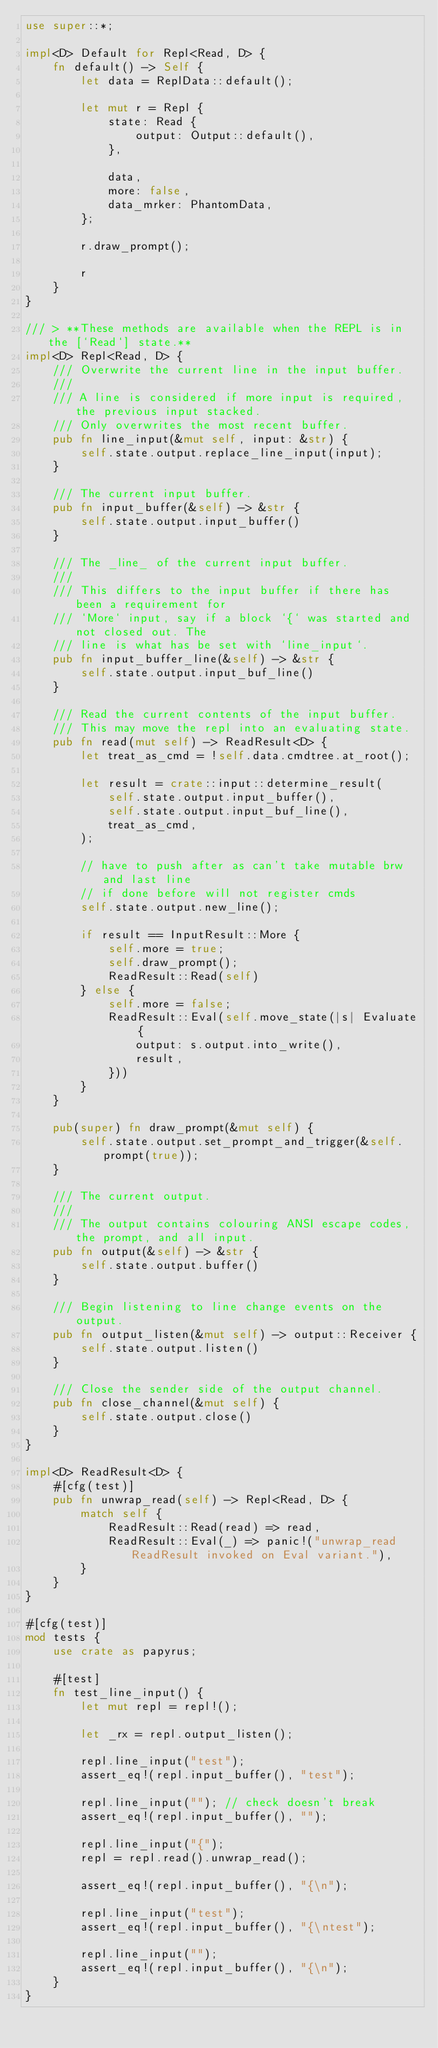<code> <loc_0><loc_0><loc_500><loc_500><_Rust_>use super::*;

impl<D> Default for Repl<Read, D> {
    fn default() -> Self {
        let data = ReplData::default();

        let mut r = Repl {
            state: Read {
                output: Output::default(),
            },

            data,
            more: false,
            data_mrker: PhantomData,
        };

        r.draw_prompt();

        r
    }
}

/// > **These methods are available when the REPL is in the [`Read`] state.**
impl<D> Repl<Read, D> {
    /// Overwrite the current line in the input buffer.
    ///
    /// A line is considered if more input is required, the previous input stacked.
    /// Only overwrites the most recent buffer.
    pub fn line_input(&mut self, input: &str) {
        self.state.output.replace_line_input(input);
    }

    /// The current input buffer.
    pub fn input_buffer(&self) -> &str {
        self.state.output.input_buffer()
    }

    /// The _line_ of the current input buffer.
    ///
    /// This differs to the input buffer if there has been a requirement for
    /// `More` input, say if a block `{` was started and not closed out. The
    /// line is what has be set with `line_input`.
    pub fn input_buffer_line(&self) -> &str {
        self.state.output.input_buf_line()
    }

    /// Read the current contents of the input buffer.
    /// This may move the repl into an evaluating state.
    pub fn read(mut self) -> ReadResult<D> {
        let treat_as_cmd = !self.data.cmdtree.at_root();

        let result = crate::input::determine_result(
            self.state.output.input_buffer(),
            self.state.output.input_buf_line(),
            treat_as_cmd,
        );

        // have to push after as can't take mutable brw and last line
        // if done before will not register cmds
        self.state.output.new_line();

        if result == InputResult::More {
            self.more = true;
            self.draw_prompt();
            ReadResult::Read(self)
        } else {
            self.more = false;
            ReadResult::Eval(self.move_state(|s| Evaluate {
                output: s.output.into_write(),
                result,
            }))
        }
    }

    pub(super) fn draw_prompt(&mut self) {
        self.state.output.set_prompt_and_trigger(&self.prompt(true));
    }

    /// The current output.
    ///
    /// The output contains colouring ANSI escape codes, the prompt, and all input.
    pub fn output(&self) -> &str {
        self.state.output.buffer()
    }

    /// Begin listening to line change events on the output.
    pub fn output_listen(&mut self) -> output::Receiver {
        self.state.output.listen()
    }

    /// Close the sender side of the output channel.
    pub fn close_channel(&mut self) {
        self.state.output.close()
    }
}

impl<D> ReadResult<D> {
    #[cfg(test)]
    pub fn unwrap_read(self) -> Repl<Read, D> {
        match self {
            ReadResult::Read(read) => read,
            ReadResult::Eval(_) => panic!("unwrap_read ReadResult invoked on Eval variant."),
        }
    }
}

#[cfg(test)]
mod tests {
    use crate as papyrus;

    #[test]
    fn test_line_input() {
        let mut repl = repl!();

        let _rx = repl.output_listen();

        repl.line_input("test");
        assert_eq!(repl.input_buffer(), "test");

        repl.line_input(""); // check doesn't break
        assert_eq!(repl.input_buffer(), "");

        repl.line_input("{");
        repl = repl.read().unwrap_read();

        assert_eq!(repl.input_buffer(), "{\n");

        repl.line_input("test");
        assert_eq!(repl.input_buffer(), "{\ntest");

        repl.line_input("");
        assert_eq!(repl.input_buffer(), "{\n");
    }
}
</code> 